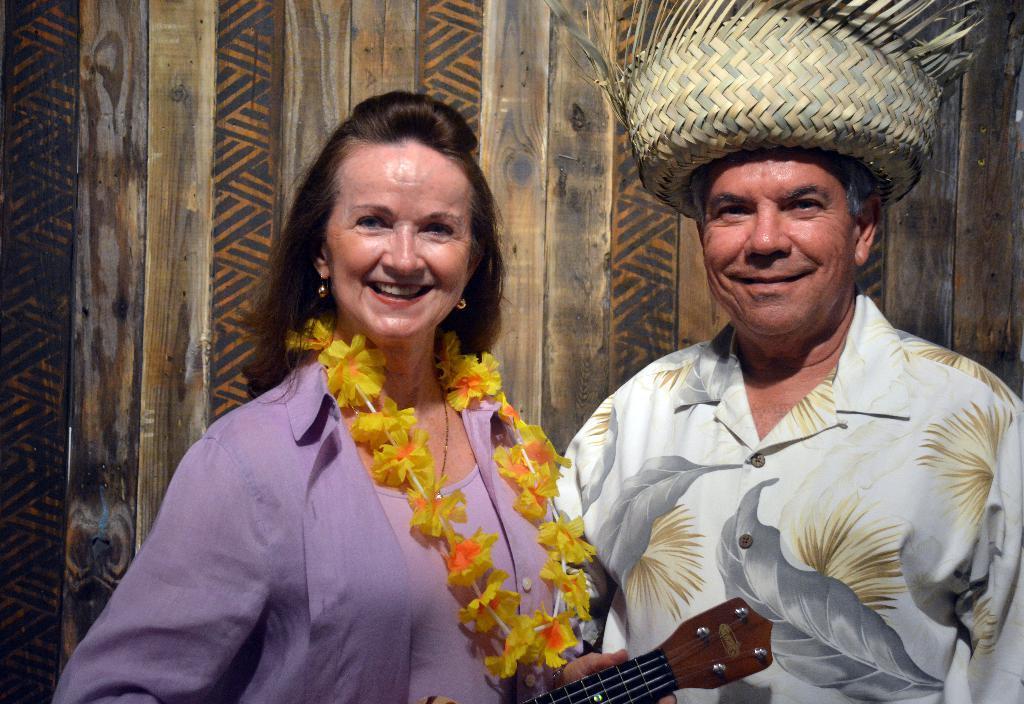Can you describe this image briefly? A couple are posing to camera. Of them the women is holding a guitar and the man is wearing a hat. 